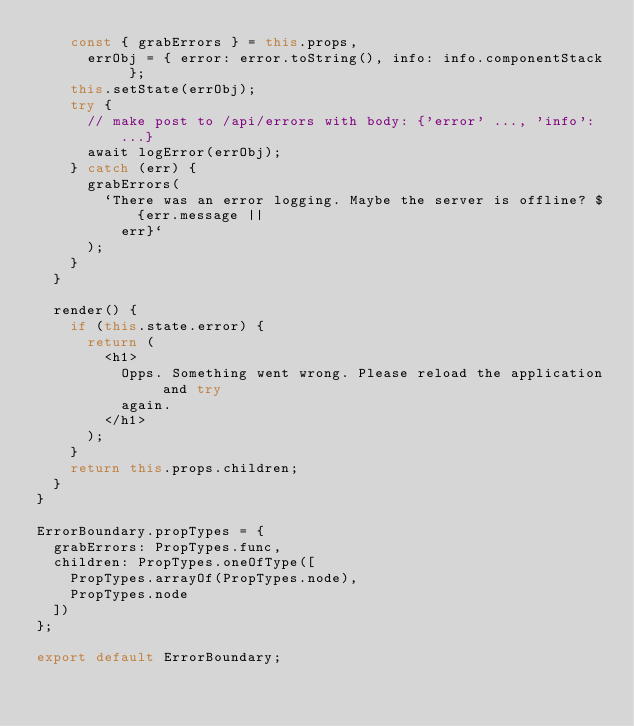<code> <loc_0><loc_0><loc_500><loc_500><_JavaScript_>    const { grabErrors } = this.props,
      errObj = { error: error.toString(), info: info.componentStack };
    this.setState(errObj);
    try {
      // make post to /api/errors with body: {'error' ..., 'info': ...}
      await logError(errObj);
    } catch (err) {
      grabErrors(
        `There was an error logging. Maybe the server is offline? ${err.message ||
          err}`
      );
    }
  }

  render() {
    if (this.state.error) {
      return (
        <h1>
          Opps. Something went wrong. Please reload the application and try
          again.
        </h1>
      );
    }
    return this.props.children;
  }
}

ErrorBoundary.propTypes = {
  grabErrors: PropTypes.func,
  children: PropTypes.oneOfType([
    PropTypes.arrayOf(PropTypes.node),
    PropTypes.node
  ])
};

export default ErrorBoundary;
</code> 